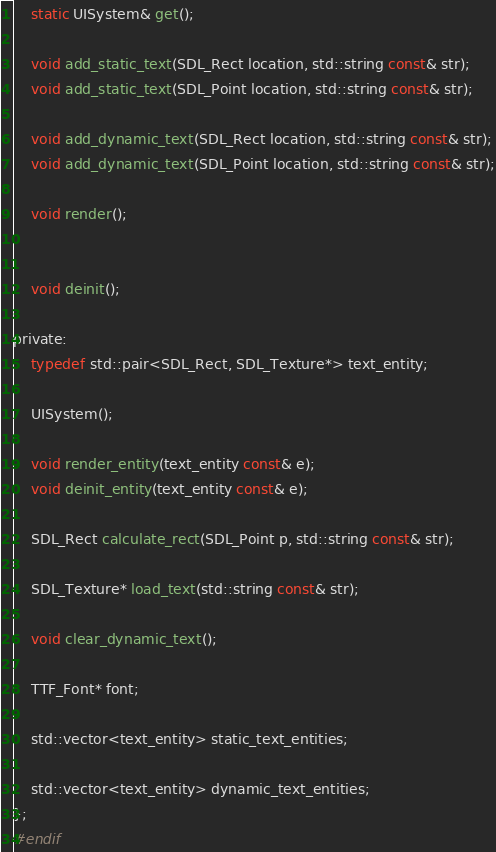<code> <loc_0><loc_0><loc_500><loc_500><_C_>    static UISystem& get();

    void add_static_text(SDL_Rect location, std::string const& str);
    void add_static_text(SDL_Point location, std::string const& str);

    void add_dynamic_text(SDL_Rect location, std::string const& str);
    void add_dynamic_text(SDL_Point location, std::string const& str);

    void render();


    void deinit();

private:
    typedef std::pair<SDL_Rect, SDL_Texture*> text_entity;

    UISystem();

    void render_entity(text_entity const& e);
    void deinit_entity(text_entity const& e);

    SDL_Rect calculate_rect(SDL_Point p, std::string const& str);

    SDL_Texture* load_text(std::string const& str);

    void clear_dynamic_text();

    TTF_Font* font;

    std::vector<text_entity> static_text_entities;

    std::vector<text_entity> dynamic_text_entities;
};
#endif
</code> 